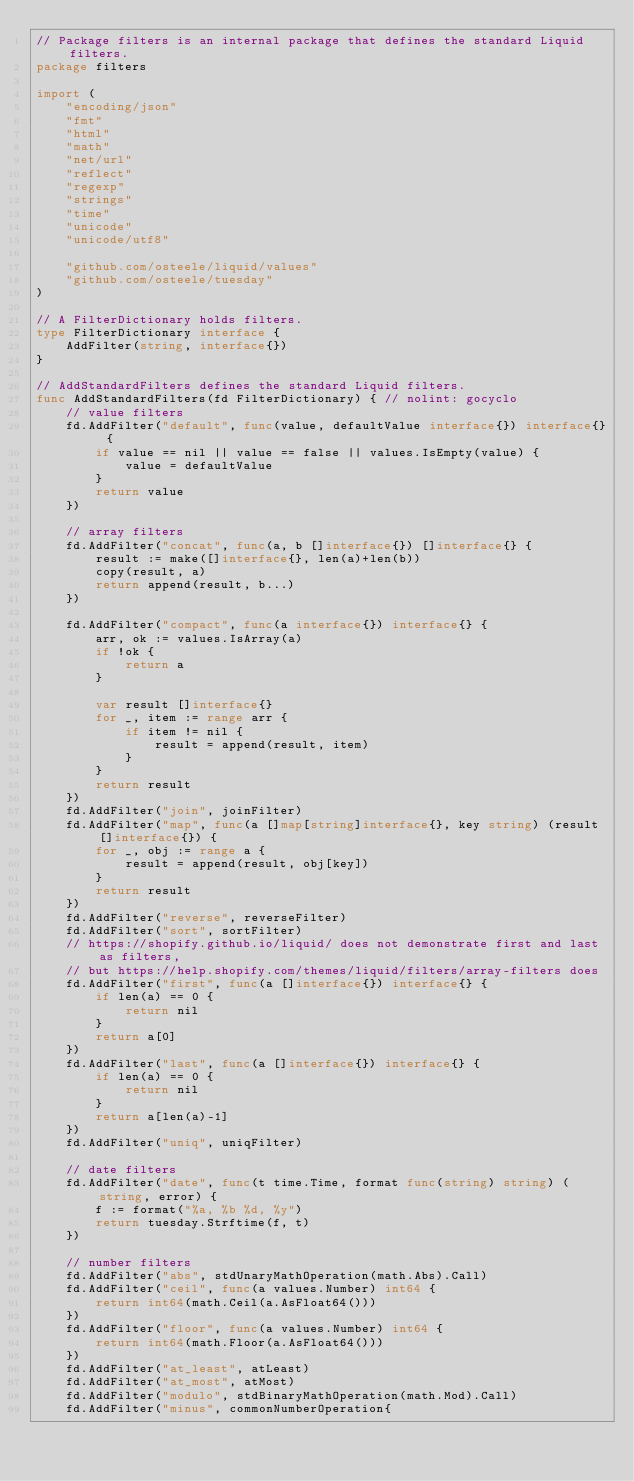Convert code to text. <code><loc_0><loc_0><loc_500><loc_500><_Go_>// Package filters is an internal package that defines the standard Liquid filters.
package filters

import (
	"encoding/json"
	"fmt"
	"html"
	"math"
	"net/url"
	"reflect"
	"regexp"
	"strings"
	"time"
	"unicode"
	"unicode/utf8"

	"github.com/osteele/liquid/values"
	"github.com/osteele/tuesday"
)

// A FilterDictionary holds filters.
type FilterDictionary interface {
	AddFilter(string, interface{})
}

// AddStandardFilters defines the standard Liquid filters.
func AddStandardFilters(fd FilterDictionary) { // nolint: gocyclo
	// value filters
	fd.AddFilter("default", func(value, defaultValue interface{}) interface{} {
		if value == nil || value == false || values.IsEmpty(value) {
			value = defaultValue
		}
		return value
	})

	// array filters
	fd.AddFilter("concat", func(a, b []interface{}) []interface{} {
		result := make([]interface{}, len(a)+len(b))
		copy(result, a)
		return append(result, b...)
	})

	fd.AddFilter("compact", func(a interface{}) interface{} {
		arr, ok := values.IsArray(a)
		if !ok {
			return a
		}

		var result []interface{}
		for _, item := range arr {
			if item != nil {
				result = append(result, item)
			}
		}
		return result
	})
	fd.AddFilter("join", joinFilter)
	fd.AddFilter("map", func(a []map[string]interface{}, key string) (result []interface{}) {
		for _, obj := range a {
			result = append(result, obj[key])
		}
		return result
	})
	fd.AddFilter("reverse", reverseFilter)
	fd.AddFilter("sort", sortFilter)
	// https://shopify.github.io/liquid/ does not demonstrate first and last as filters,
	// but https://help.shopify.com/themes/liquid/filters/array-filters does
	fd.AddFilter("first", func(a []interface{}) interface{} {
		if len(a) == 0 {
			return nil
		}
		return a[0]
	})
	fd.AddFilter("last", func(a []interface{}) interface{} {
		if len(a) == 0 {
			return nil
		}
		return a[len(a)-1]
	})
	fd.AddFilter("uniq", uniqFilter)

	// date filters
	fd.AddFilter("date", func(t time.Time, format func(string) string) (string, error) {
		f := format("%a, %b %d, %y")
		return tuesday.Strftime(f, t)
	})

	// number filters
	fd.AddFilter("abs", stdUnaryMathOperation(math.Abs).Call)
	fd.AddFilter("ceil", func(a values.Number) int64 {
		return int64(math.Ceil(a.AsFloat64()))
	})
	fd.AddFilter("floor", func(a values.Number) int64 {
		return int64(math.Floor(a.AsFloat64()))
	})
	fd.AddFilter("at_least", atLeast)
	fd.AddFilter("at_most", atMost)
	fd.AddFilter("modulo", stdBinaryMathOperation(math.Mod).Call)
	fd.AddFilter("minus", commonNumberOperation{</code> 